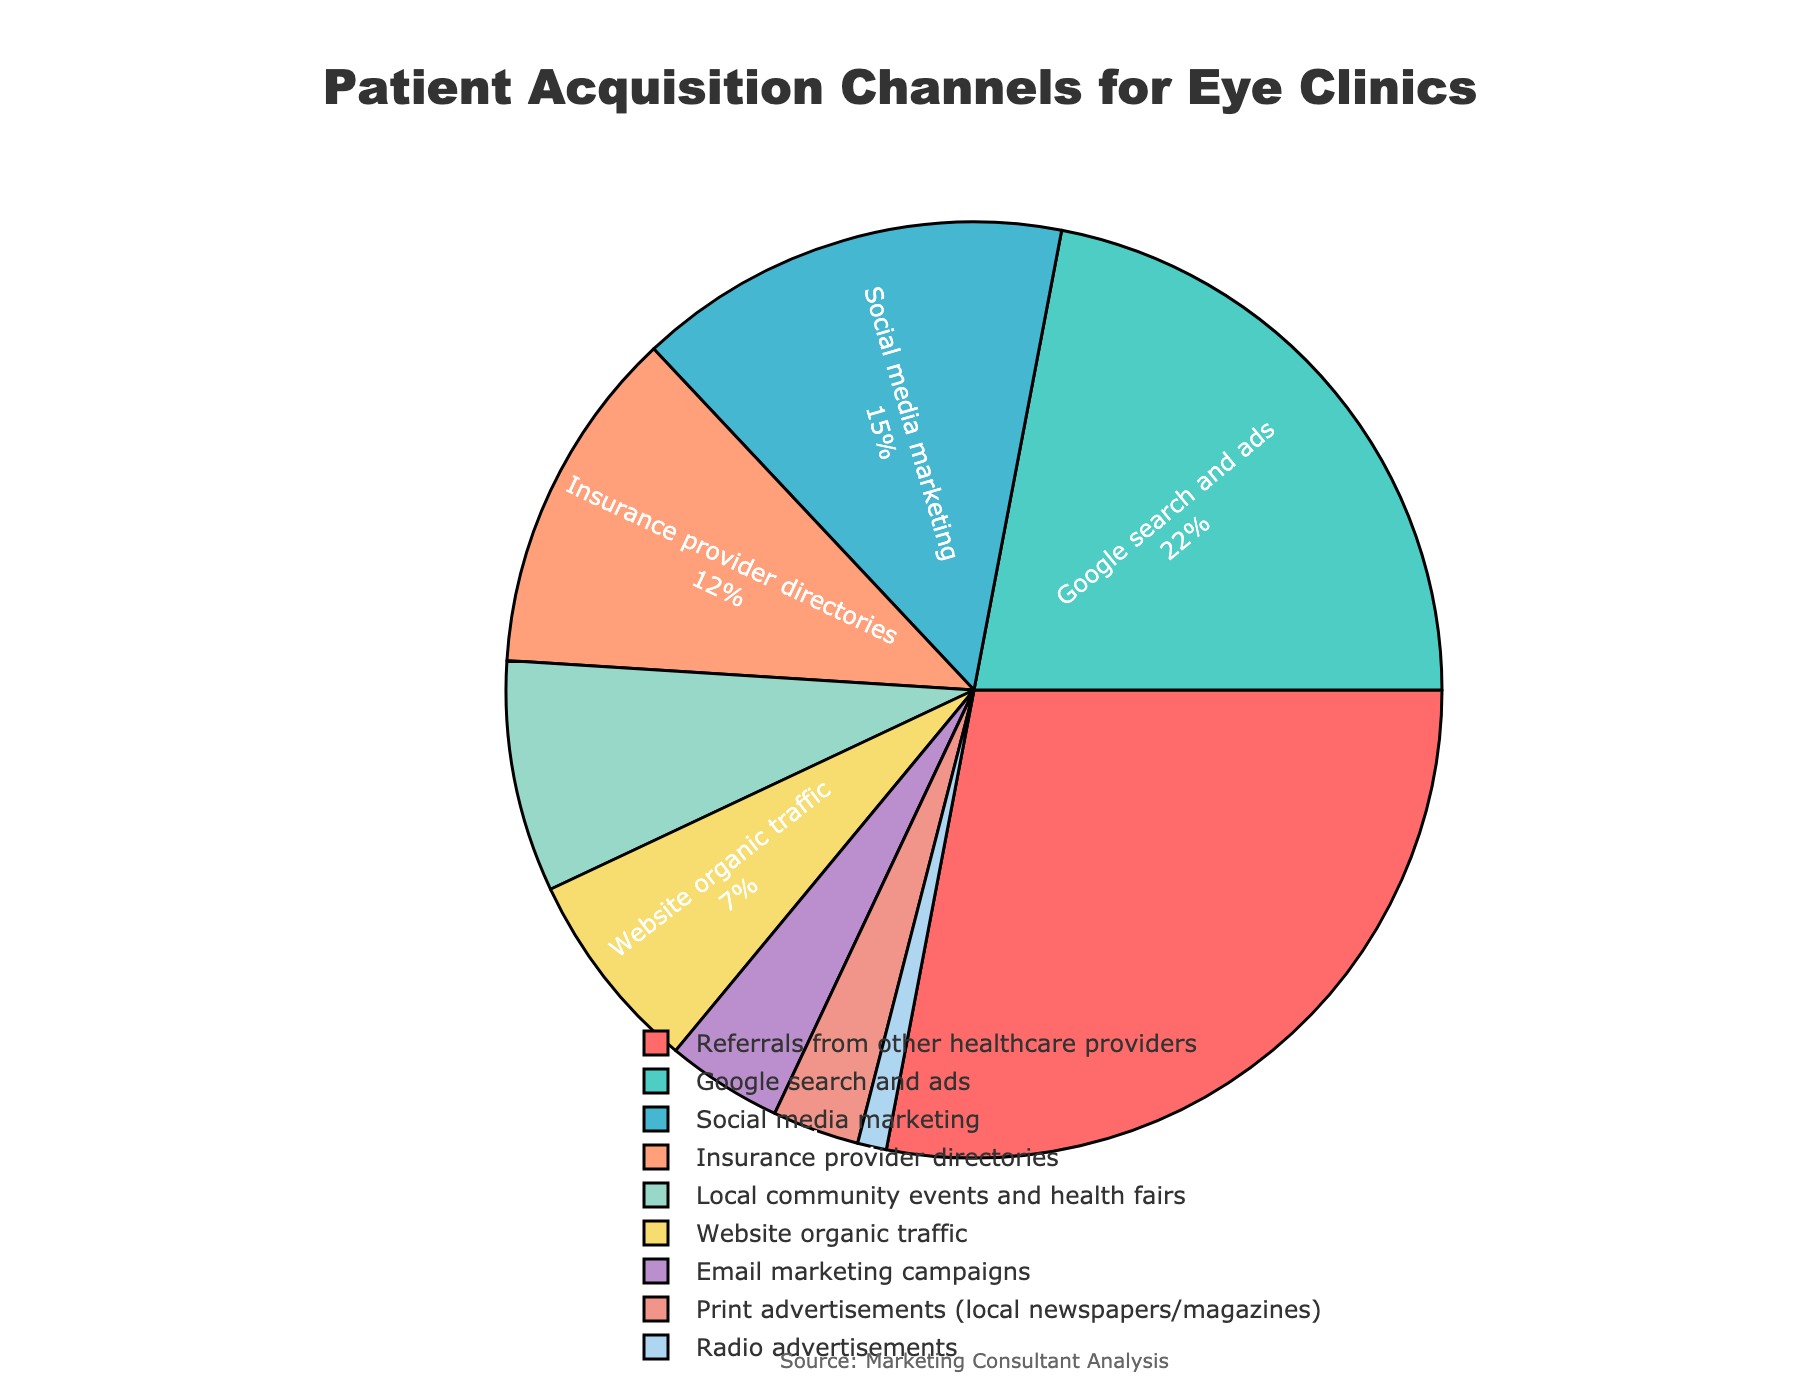What is the most common patient acquisition channel? Referrals from other healthcare providers have the largest percentage slice in the pie chart, indicating the highest share.
Answer: Referrals from other healthcare providers Which two channels combined contribute more than Google search and ads? Social media marketing and insurance provider directories combined contribute 15% + 12% = 27%, which is greater than the 22% contributed by Google search and ads.
Answer: Social media marketing and insurance provider directories What percentage of patients are acquired through local community events and health fairs, email marketing campaigns, and print advertisements combined? Summing the percentages: 8% (local community events and health fairs) + 4% (email marketing campaigns) + 3% (print advertisements), we get 8 + 4 + 3 = 15%.
Answer: 15% Which channel has the smallest share in patient acquisition? The smallest slice of the pie chart is labeled for radio advertisements, showing only 1%.
Answer: Radio advertisements How does the percentage of patients acquired through website organic traffic compare to that acquired through email marketing campaigns? Website organic traffic has a 7% share, whereas email marketing campaigns have a 4% share. Therefore, website organic traffic is greater by 3 percentage points.
Answer: Website organic traffic is greater than email marketing campaigns by 3 percentage points What is the difference in percentage between the largest and smallest patient acquisition channels? The largest channel, referrals from other healthcare providers, has 28%, and the smallest, radio advertisements, has 1%. The difference is 28 - 1 = 27%.
Answer: 27% Which methods together contribute to almost half the patient acquisition, and how much is their combined percentage? Referrals from other healthcare providers (28%) and Google search and ads (22%) together contribute 28 + 22 = 50%, which is half of the total acquisition.
Answer: Referrals from other healthcare providers and Google search and ads, 50% What color represents insurance provider directories in the pie chart? According to the provided custom color scale order, insurance provider directories are assigned the fifth color in the list, which is yellow.
Answer: Yellow If we wanted to target the top three channels to increase patient acquisition, which channels would we choose? The top three channels indicated by the largest slices in descending order are referrals from other healthcare providers (28%), Google search and ads (22%), and social media marketing (15%).
Answer: Referrals from other healthcare providers, Google search and ads, and social media marketing 